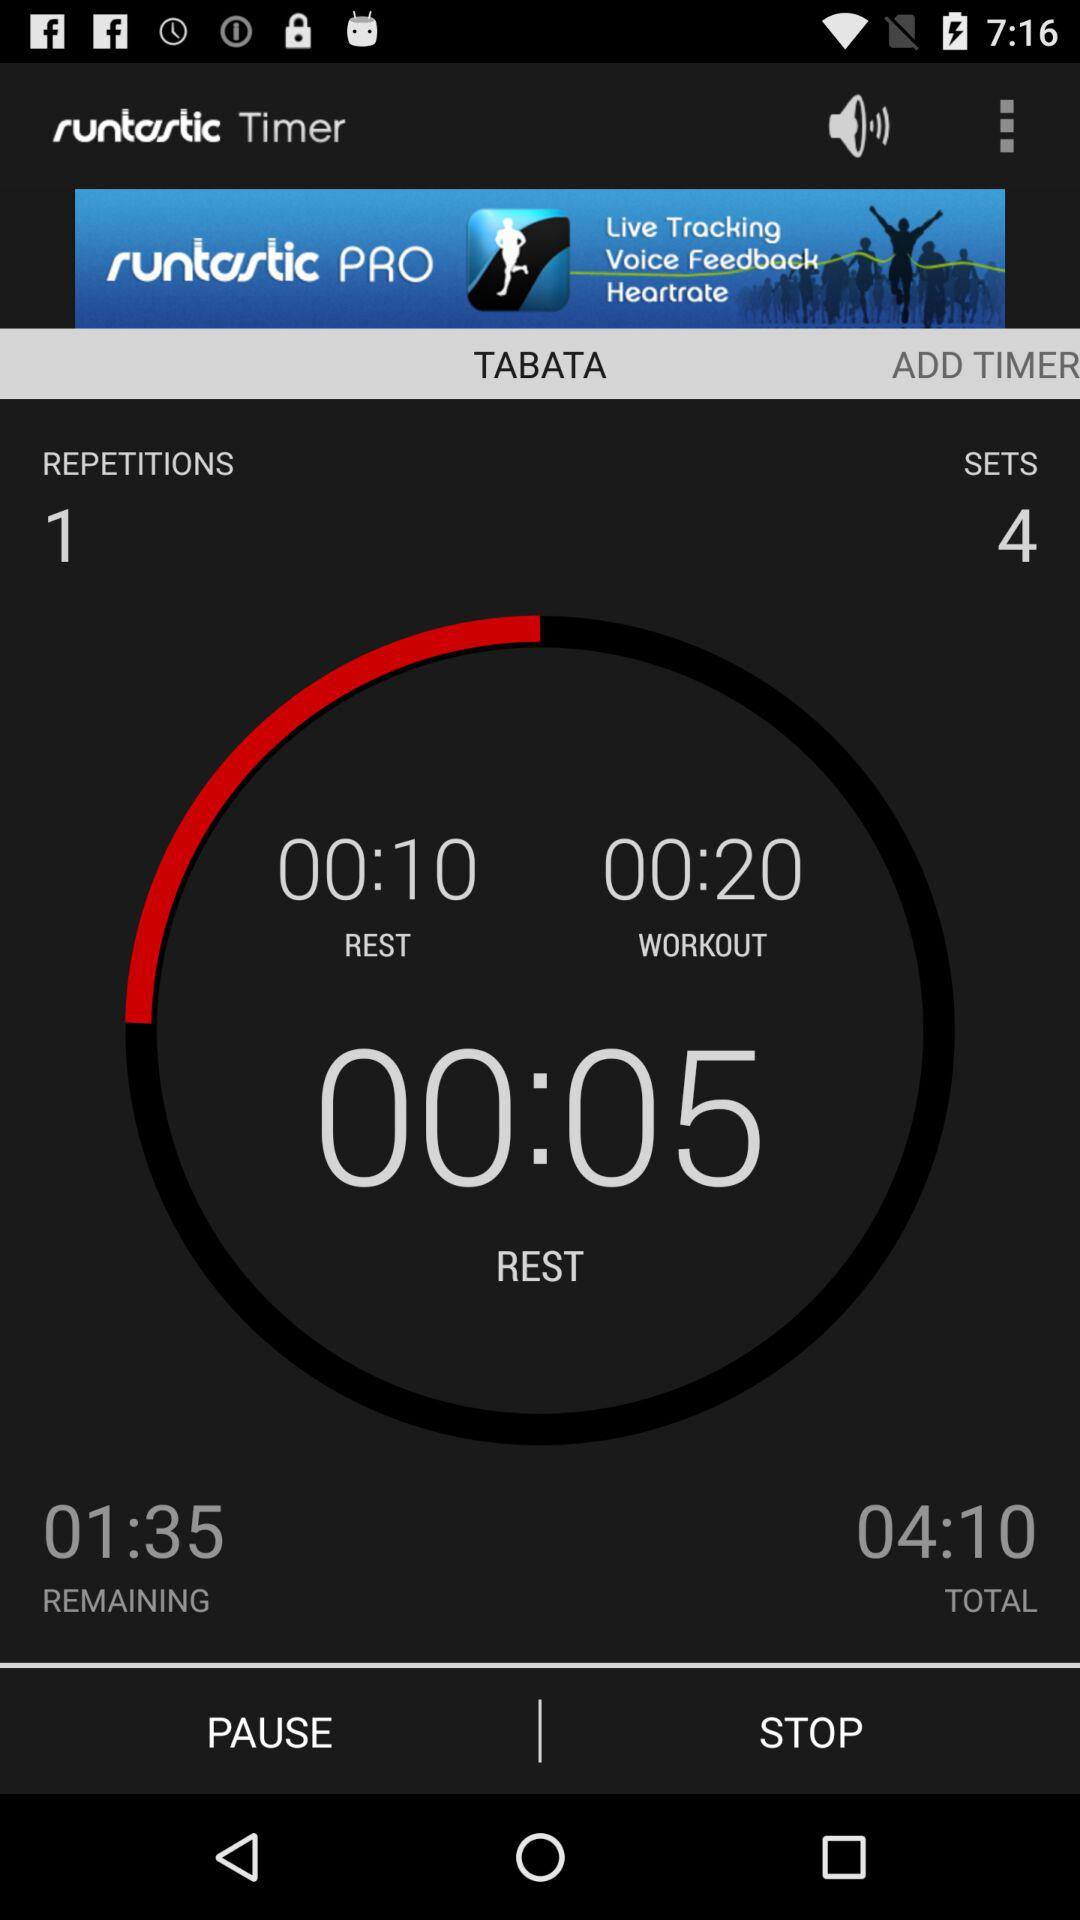What is the total number of sets? The total number of sets is 4. 